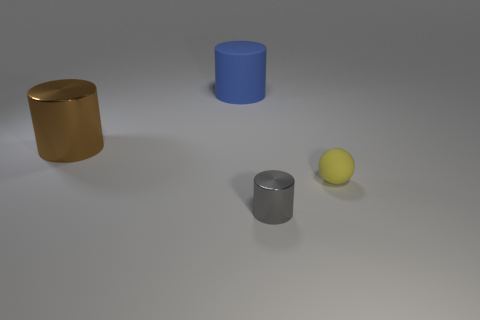There is a metallic object that is behind the small ball; how big is it?
Make the answer very short. Large. What number of balls are either tiny gray metal things or metal things?
Offer a very short reply. 0. What is the shape of the thing that is both on the right side of the big brown cylinder and behind the tiny ball?
Your response must be concise. Cylinder. Is there another gray cylinder of the same size as the gray metallic cylinder?
Offer a terse response. No. How many objects are either large objects on the right side of the big metallic cylinder or tiny gray rubber balls?
Ensure brevity in your answer.  1. Do the small gray cylinder and the big blue cylinder behind the small cylinder have the same material?
Provide a short and direct response. No. What number of other objects are the same shape as the blue rubber object?
Give a very brief answer. 2. How many things are either metallic cylinders left of the big blue thing or metal objects that are behind the ball?
Provide a succinct answer. 1. Are there fewer tiny balls to the left of the yellow rubber ball than small cylinders right of the brown cylinder?
Keep it short and to the point. Yes. How many big cyan metal objects are there?
Keep it short and to the point. 0. 